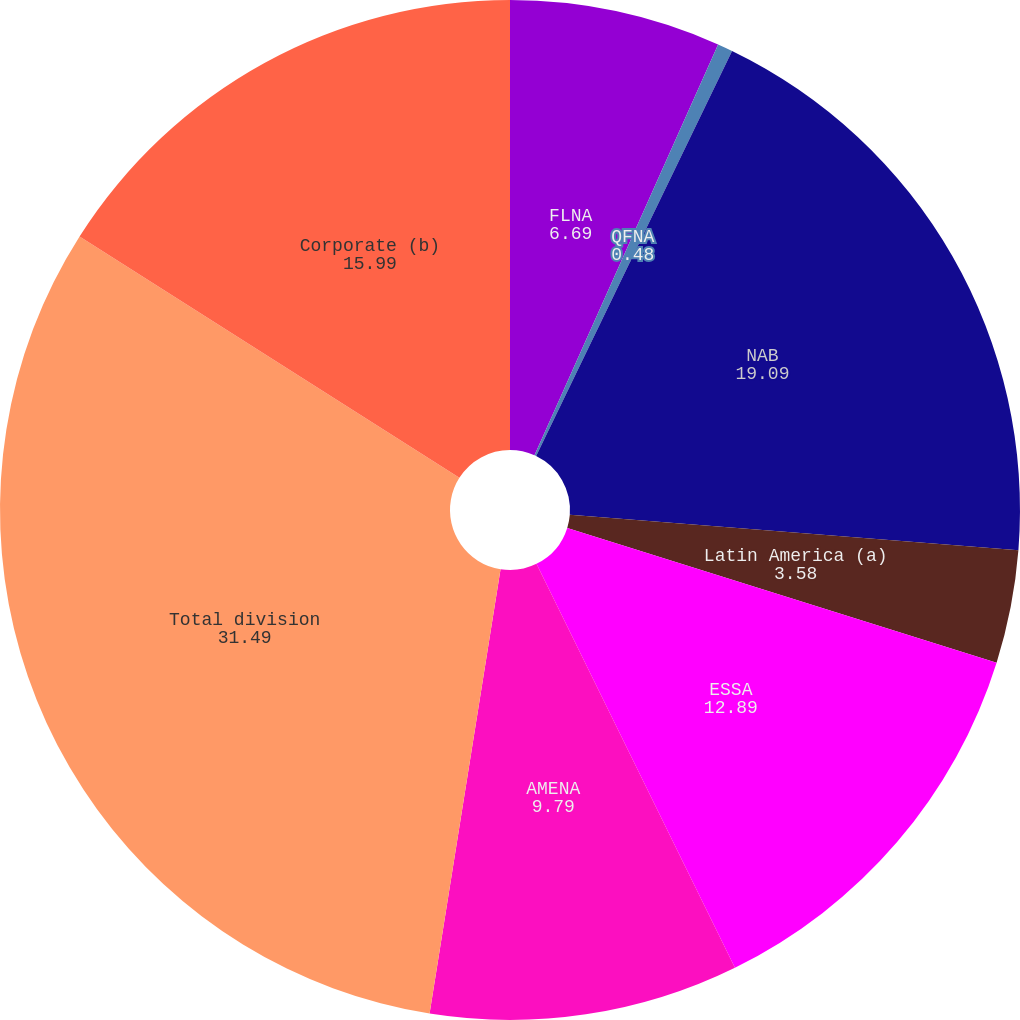Convert chart. <chart><loc_0><loc_0><loc_500><loc_500><pie_chart><fcel>FLNA<fcel>QFNA<fcel>NAB<fcel>Latin America (a)<fcel>ESSA<fcel>AMENA<fcel>Total division<fcel>Corporate (b)<nl><fcel>6.69%<fcel>0.48%<fcel>19.09%<fcel>3.58%<fcel>12.89%<fcel>9.79%<fcel>31.49%<fcel>15.99%<nl></chart> 